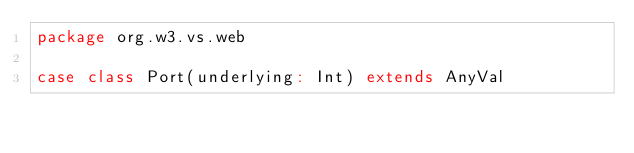<code> <loc_0><loc_0><loc_500><loc_500><_Scala_>package org.w3.vs.web

case class Port(underlying: Int) extends AnyVal
</code> 